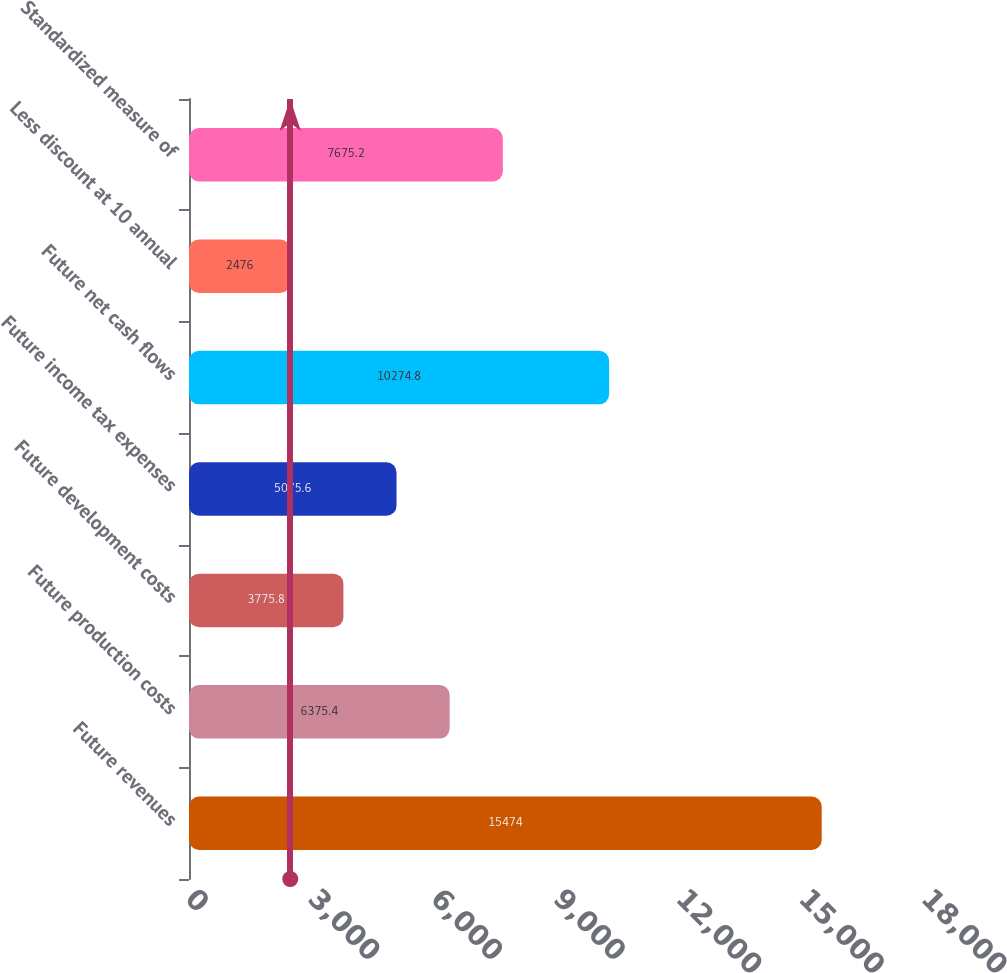<chart> <loc_0><loc_0><loc_500><loc_500><bar_chart><fcel>Future revenues<fcel>Future production costs<fcel>Future development costs<fcel>Future income tax expenses<fcel>Future net cash flows<fcel>Less discount at 10 annual<fcel>Standardized measure of<nl><fcel>15474<fcel>6375.4<fcel>3775.8<fcel>5075.6<fcel>10274.8<fcel>2476<fcel>7675.2<nl></chart> 